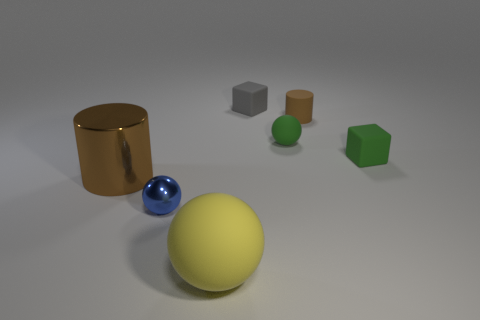Subtract all small balls. How many balls are left? 1 Subtract all yellow spheres. How many spheres are left? 2 Add 2 yellow rubber objects. How many objects exist? 9 Subtract all cubes. How many objects are left? 5 Add 3 small red shiny balls. How many small red shiny balls exist? 3 Subtract 1 gray blocks. How many objects are left? 6 Subtract 1 cylinders. How many cylinders are left? 1 Subtract all cyan balls. Subtract all purple cylinders. How many balls are left? 3 Subtract all big green cubes. Subtract all large yellow spheres. How many objects are left? 6 Add 5 small blue things. How many small blue things are left? 6 